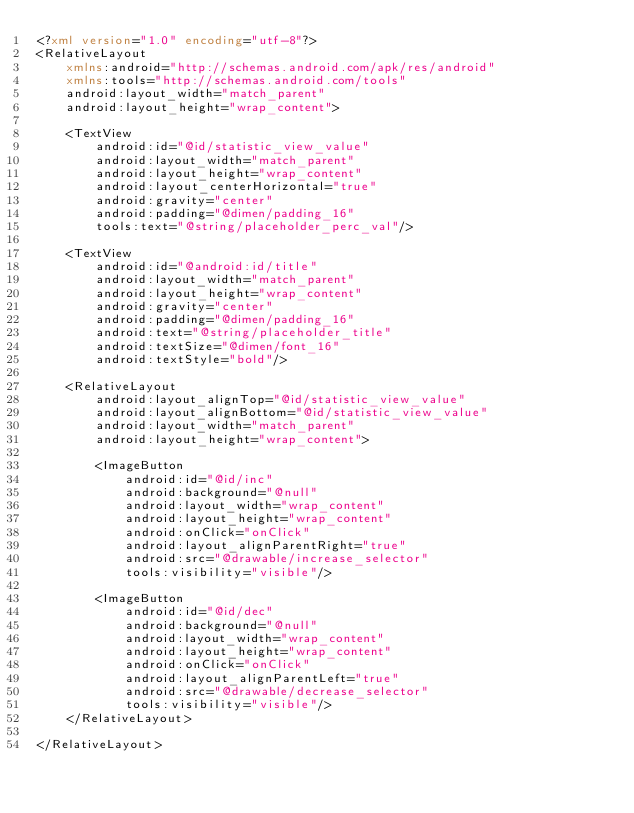Convert code to text. <code><loc_0><loc_0><loc_500><loc_500><_XML_><?xml version="1.0" encoding="utf-8"?>
<RelativeLayout
    xmlns:android="http://schemas.android.com/apk/res/android"
    xmlns:tools="http://schemas.android.com/tools"
    android:layout_width="match_parent"
    android:layout_height="wrap_content">

    <TextView
        android:id="@id/statistic_view_value"
        android:layout_width="match_parent"
        android:layout_height="wrap_content"
        android:layout_centerHorizontal="true"
        android:gravity="center"
        android:padding="@dimen/padding_16"
        tools:text="@string/placeholder_perc_val"/>

    <TextView
        android:id="@android:id/title"
        android:layout_width="match_parent"
        android:layout_height="wrap_content"
        android:gravity="center"
        android:padding="@dimen/padding_16"
        android:text="@string/placeholder_title"
        android:textSize="@dimen/font_16"
        android:textStyle="bold"/>

    <RelativeLayout
        android:layout_alignTop="@id/statistic_view_value"
        android:layout_alignBottom="@id/statistic_view_value"
        android:layout_width="match_parent"
        android:layout_height="wrap_content">

        <ImageButton
            android:id="@id/inc"
            android:background="@null"
            android:layout_width="wrap_content"
            android:layout_height="wrap_content"
            android:onClick="onClick"
            android:layout_alignParentRight="true"
            android:src="@drawable/increase_selector"
            tools:visibility="visible"/>

        <ImageButton
            android:id="@id/dec"
            android:background="@null"
            android:layout_width="wrap_content"
            android:layout_height="wrap_content"
            android:onClick="onClick"
            android:layout_alignParentLeft="true"
            android:src="@drawable/decrease_selector"
            tools:visibility="visible"/>
    </RelativeLayout>

</RelativeLayout></code> 